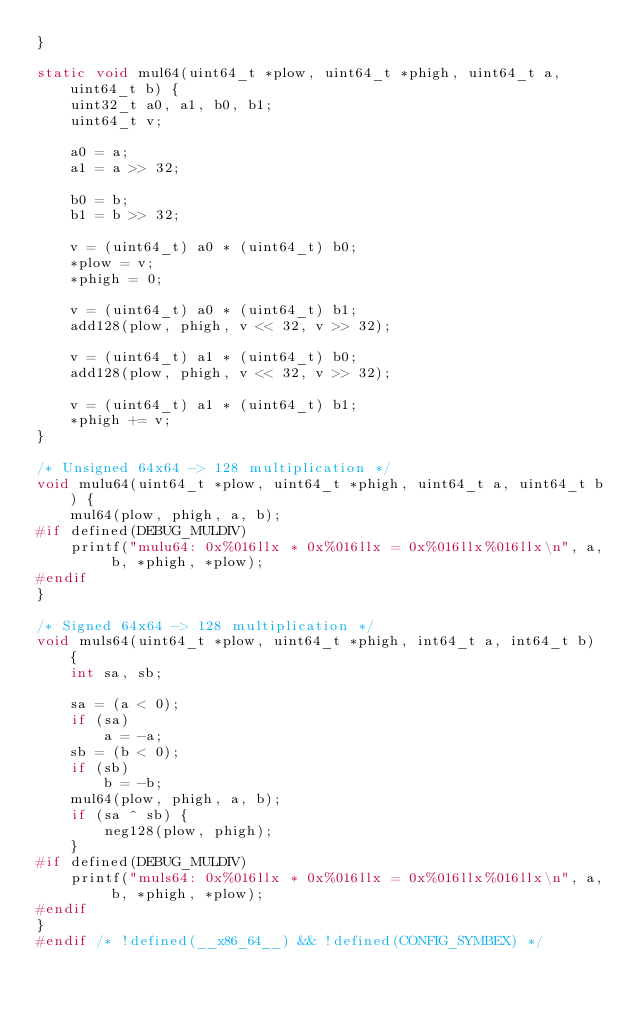<code> <loc_0><loc_0><loc_500><loc_500><_C_>}

static void mul64(uint64_t *plow, uint64_t *phigh, uint64_t a, uint64_t b) {
    uint32_t a0, a1, b0, b1;
    uint64_t v;

    a0 = a;
    a1 = a >> 32;

    b0 = b;
    b1 = b >> 32;

    v = (uint64_t) a0 * (uint64_t) b0;
    *plow = v;
    *phigh = 0;

    v = (uint64_t) a0 * (uint64_t) b1;
    add128(plow, phigh, v << 32, v >> 32);

    v = (uint64_t) a1 * (uint64_t) b0;
    add128(plow, phigh, v << 32, v >> 32);

    v = (uint64_t) a1 * (uint64_t) b1;
    *phigh += v;
}

/* Unsigned 64x64 -> 128 multiplication */
void mulu64(uint64_t *plow, uint64_t *phigh, uint64_t a, uint64_t b) {
    mul64(plow, phigh, a, b);
#if defined(DEBUG_MULDIV)
    printf("mulu64: 0x%016llx * 0x%016llx = 0x%016llx%016llx\n", a, b, *phigh, *plow);
#endif
}

/* Signed 64x64 -> 128 multiplication */
void muls64(uint64_t *plow, uint64_t *phigh, int64_t a, int64_t b) {
    int sa, sb;

    sa = (a < 0);
    if (sa)
        a = -a;
    sb = (b < 0);
    if (sb)
        b = -b;
    mul64(plow, phigh, a, b);
    if (sa ^ sb) {
        neg128(plow, phigh);
    }
#if defined(DEBUG_MULDIV)
    printf("muls64: 0x%016llx * 0x%016llx = 0x%016llx%016llx\n", a, b, *phigh, *plow);
#endif
}
#endif /* !defined(__x86_64__) && !defined(CONFIG_SYMBEX) */
</code> 